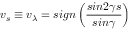<formula> <loc_0><loc_0><loc_500><loc_500>{ v } _ { s } \equiv v _ { \lambda } = s i g n \left ( \frac { \sin 2 \gamma s } { \sin \gamma } \right )</formula> 